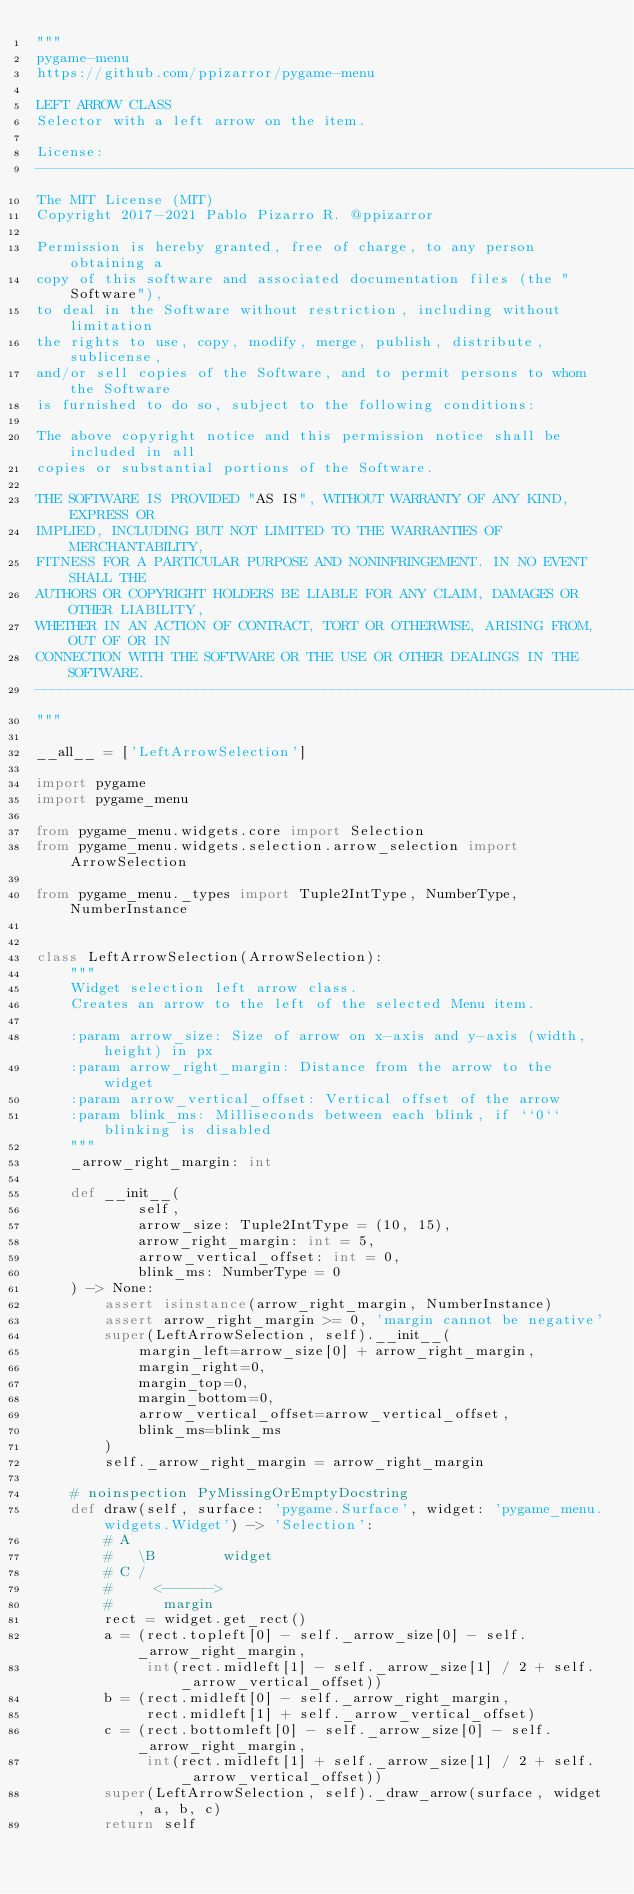Convert code to text. <code><loc_0><loc_0><loc_500><loc_500><_Python_>"""
pygame-menu
https://github.com/ppizarror/pygame-menu

LEFT ARROW CLASS
Selector with a left arrow on the item.

License:
-------------------------------------------------------------------------------
The MIT License (MIT)
Copyright 2017-2021 Pablo Pizarro R. @ppizarror

Permission is hereby granted, free of charge, to any person obtaining a
copy of this software and associated documentation files (the "Software"),
to deal in the Software without restriction, including without limitation
the rights to use, copy, modify, merge, publish, distribute, sublicense,
and/or sell copies of the Software, and to permit persons to whom the Software
is furnished to do so, subject to the following conditions:

The above copyright notice and this permission notice shall be included in all
copies or substantial portions of the Software.

THE SOFTWARE IS PROVIDED "AS IS", WITHOUT WARRANTY OF ANY KIND, EXPRESS OR
IMPLIED, INCLUDING BUT NOT LIMITED TO THE WARRANTIES OF MERCHANTABILITY,
FITNESS FOR A PARTICULAR PURPOSE AND NONINFRINGEMENT. IN NO EVENT SHALL THE
AUTHORS OR COPYRIGHT HOLDERS BE LIABLE FOR ANY CLAIM, DAMAGES OR OTHER LIABILITY,
WHETHER IN AN ACTION OF CONTRACT, TORT OR OTHERWISE, ARISING FROM, OUT OF OR IN
CONNECTION WITH THE SOFTWARE OR THE USE OR OTHER DEALINGS IN THE SOFTWARE.
-------------------------------------------------------------------------------
"""

__all__ = ['LeftArrowSelection']

import pygame
import pygame_menu

from pygame_menu.widgets.core import Selection
from pygame_menu.widgets.selection.arrow_selection import ArrowSelection

from pygame_menu._types import Tuple2IntType, NumberType, NumberInstance


class LeftArrowSelection(ArrowSelection):
    """
    Widget selection left arrow class.
    Creates an arrow to the left of the selected Menu item.

    :param arrow_size: Size of arrow on x-axis and y-axis (width, height) in px
    :param arrow_right_margin: Distance from the arrow to the widget
    :param arrow_vertical_offset: Vertical offset of the arrow
    :param blink_ms: Milliseconds between each blink, if ``0`` blinking is disabled
    """
    _arrow_right_margin: int

    def __init__(
            self,
            arrow_size: Tuple2IntType = (10, 15),
            arrow_right_margin: int = 5,
            arrow_vertical_offset: int = 0,
            blink_ms: NumberType = 0
    ) -> None:
        assert isinstance(arrow_right_margin, NumberInstance)
        assert arrow_right_margin >= 0, 'margin cannot be negative'
        super(LeftArrowSelection, self).__init__(
            margin_left=arrow_size[0] + arrow_right_margin,
            margin_right=0,
            margin_top=0,
            margin_bottom=0,
            arrow_vertical_offset=arrow_vertical_offset,
            blink_ms=blink_ms
        )
        self._arrow_right_margin = arrow_right_margin

    # noinspection PyMissingOrEmptyDocstring
    def draw(self, surface: 'pygame.Surface', widget: 'pygame_menu.widgets.Widget') -> 'Selection':
        # A
        #   \B        widget
        # C /
        #     <------>
        #      margin
        rect = widget.get_rect()
        a = (rect.topleft[0] - self._arrow_size[0] - self._arrow_right_margin,
             int(rect.midleft[1] - self._arrow_size[1] / 2 + self._arrow_vertical_offset))
        b = (rect.midleft[0] - self._arrow_right_margin,
             rect.midleft[1] + self._arrow_vertical_offset)
        c = (rect.bottomleft[0] - self._arrow_size[0] - self._arrow_right_margin,
             int(rect.midleft[1] + self._arrow_size[1] / 2 + self._arrow_vertical_offset))
        super(LeftArrowSelection, self)._draw_arrow(surface, widget, a, b, c)
        return self
</code> 